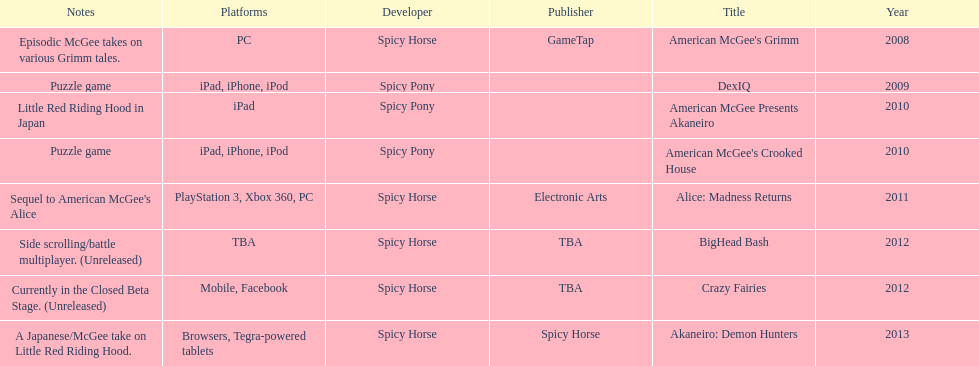What is the first title on this chart? American McGee's Grimm. Can you give me this table as a dict? {'header': ['Notes', 'Platforms', 'Developer', 'Publisher', 'Title', 'Year'], 'rows': [['Episodic McGee takes on various Grimm tales.', 'PC', 'Spicy Horse', 'GameTap', "American McGee's Grimm", '2008'], ['Puzzle game', 'iPad, iPhone, iPod', 'Spicy Pony', '', 'DexIQ', '2009'], ['Little Red Riding Hood in Japan', 'iPad', 'Spicy Pony', '', 'American McGee Presents Akaneiro', '2010'], ['Puzzle game', 'iPad, iPhone, iPod', 'Spicy Pony', '', "American McGee's Crooked House", '2010'], ["Sequel to American McGee's Alice", 'PlayStation 3, Xbox 360, PC', 'Spicy Horse', 'Electronic Arts', 'Alice: Madness Returns', '2011'], ['Side scrolling/battle multiplayer. (Unreleased)', 'TBA', 'Spicy Horse', 'TBA', 'BigHead Bash', '2012'], ['Currently in the Closed Beta Stage. (Unreleased)', 'Mobile, Facebook', 'Spicy Horse', 'TBA', 'Crazy Fairies', '2012'], ['A Japanese/McGee take on Little Red Riding Hood.', 'Browsers, Tegra-powered tablets', 'Spicy Horse', 'Spicy Horse', 'Akaneiro: Demon Hunters', '2013']]} 